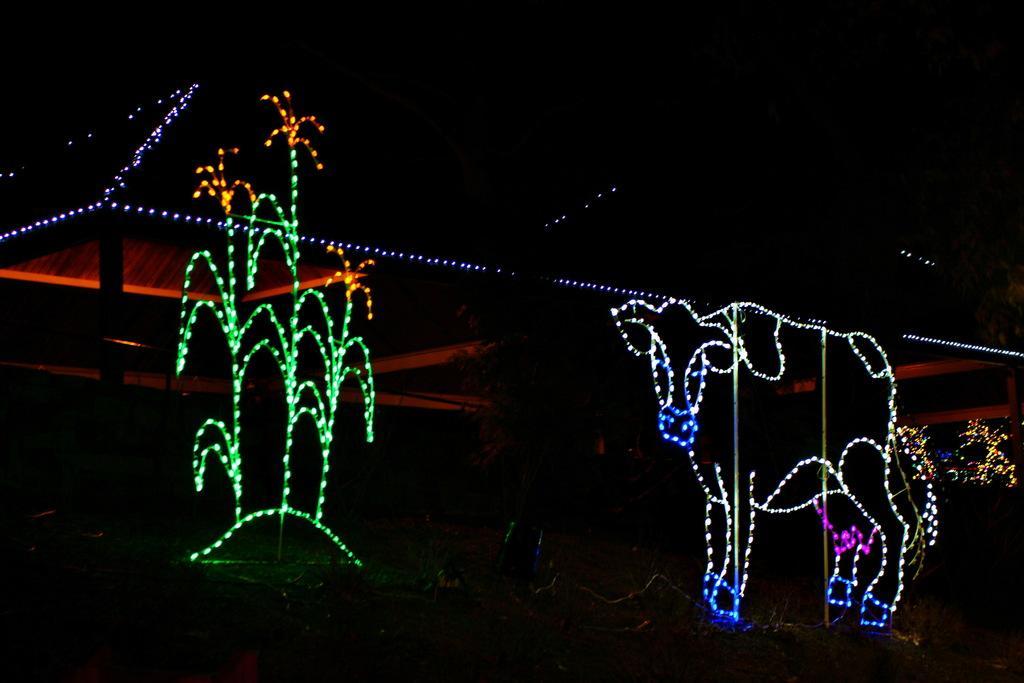Describe this image in one or two sentences. In this image in the background there might be a building , in front of building there are lighting in the form of tree and animal. 